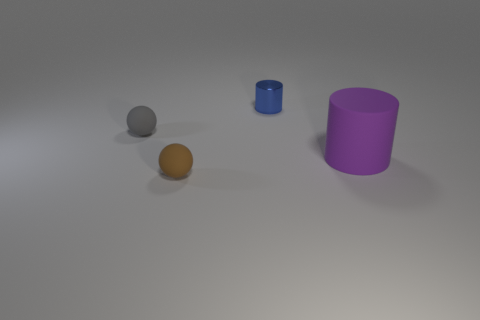Add 1 gray matte balls. How many objects exist? 5 Add 4 big rubber objects. How many big rubber objects exist? 5 Subtract 0 red spheres. How many objects are left? 4 Subtract all large red cylinders. Subtract all big purple things. How many objects are left? 3 Add 1 purple rubber cylinders. How many purple rubber cylinders are left? 2 